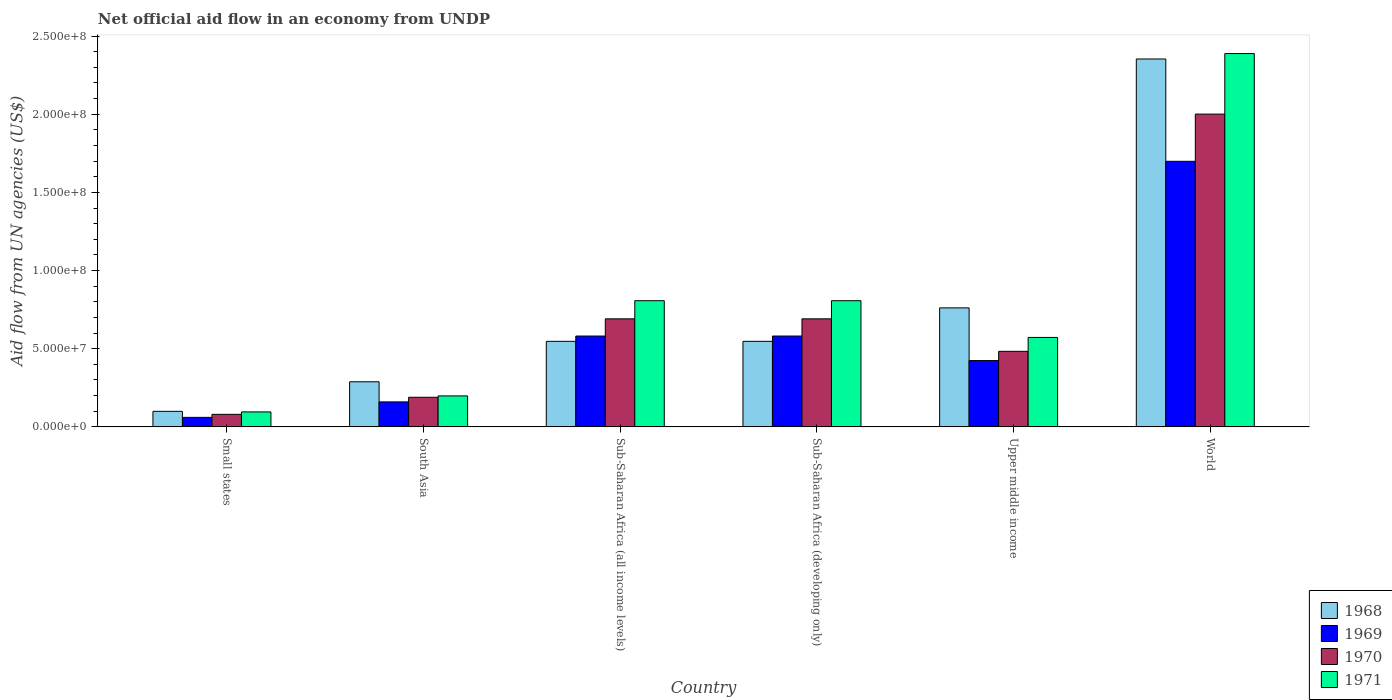How many different coloured bars are there?
Provide a short and direct response. 4. How many bars are there on the 5th tick from the left?
Your answer should be very brief. 4. How many bars are there on the 5th tick from the right?
Your answer should be very brief. 4. What is the label of the 3rd group of bars from the left?
Ensure brevity in your answer.  Sub-Saharan Africa (all income levels). What is the net official aid flow in 1968 in Sub-Saharan Africa (all income levels)?
Your answer should be compact. 5.47e+07. Across all countries, what is the maximum net official aid flow in 1968?
Your answer should be compact. 2.35e+08. Across all countries, what is the minimum net official aid flow in 1968?
Your answer should be compact. 9.94e+06. In which country was the net official aid flow in 1969 minimum?
Provide a succinct answer. Small states. What is the total net official aid flow in 1970 in the graph?
Provide a succinct answer. 4.14e+08. What is the difference between the net official aid flow in 1971 in Sub-Saharan Africa (developing only) and that in Upper middle income?
Offer a very short reply. 2.35e+07. What is the difference between the net official aid flow in 1971 in Small states and the net official aid flow in 1970 in Sub-Saharan Africa (developing only)?
Keep it short and to the point. -5.95e+07. What is the average net official aid flow in 1971 per country?
Your response must be concise. 8.11e+07. What is the difference between the net official aid flow of/in 1971 and net official aid flow of/in 1969 in Upper middle income?
Keep it short and to the point. 1.48e+07. What is the ratio of the net official aid flow in 1971 in Sub-Saharan Africa (all income levels) to that in World?
Provide a succinct answer. 0.34. Is the difference between the net official aid flow in 1971 in Sub-Saharan Africa (all income levels) and Upper middle income greater than the difference between the net official aid flow in 1969 in Sub-Saharan Africa (all income levels) and Upper middle income?
Provide a short and direct response. Yes. What is the difference between the highest and the second highest net official aid flow in 1971?
Offer a very short reply. 1.58e+08. What is the difference between the highest and the lowest net official aid flow in 1970?
Offer a very short reply. 1.92e+08. What does the 3rd bar from the left in World represents?
Offer a very short reply. 1970. What does the 4th bar from the right in Upper middle income represents?
Offer a very short reply. 1968. How many bars are there?
Ensure brevity in your answer.  24. How many countries are there in the graph?
Keep it short and to the point. 6. What is the difference between two consecutive major ticks on the Y-axis?
Provide a succinct answer. 5.00e+07. Are the values on the major ticks of Y-axis written in scientific E-notation?
Your response must be concise. Yes. How are the legend labels stacked?
Your answer should be compact. Vertical. What is the title of the graph?
Your answer should be very brief. Net official aid flow in an economy from UNDP. What is the label or title of the X-axis?
Provide a succinct answer. Country. What is the label or title of the Y-axis?
Offer a very short reply. Aid flow from UN agencies (US$). What is the Aid flow from UN agencies (US$) in 1968 in Small states?
Ensure brevity in your answer.  9.94e+06. What is the Aid flow from UN agencies (US$) in 1969 in Small states?
Keep it short and to the point. 6.08e+06. What is the Aid flow from UN agencies (US$) of 1970 in Small states?
Your response must be concise. 8.02e+06. What is the Aid flow from UN agencies (US$) in 1971 in Small states?
Offer a very short reply. 9.57e+06. What is the Aid flow from UN agencies (US$) of 1968 in South Asia?
Provide a succinct answer. 2.88e+07. What is the Aid flow from UN agencies (US$) of 1969 in South Asia?
Your answer should be compact. 1.60e+07. What is the Aid flow from UN agencies (US$) in 1970 in South Asia?
Keep it short and to the point. 1.89e+07. What is the Aid flow from UN agencies (US$) in 1971 in South Asia?
Keep it short and to the point. 1.98e+07. What is the Aid flow from UN agencies (US$) of 1968 in Sub-Saharan Africa (all income levels)?
Your answer should be compact. 5.47e+07. What is the Aid flow from UN agencies (US$) in 1969 in Sub-Saharan Africa (all income levels)?
Offer a terse response. 5.81e+07. What is the Aid flow from UN agencies (US$) of 1970 in Sub-Saharan Africa (all income levels)?
Give a very brief answer. 6.91e+07. What is the Aid flow from UN agencies (US$) of 1971 in Sub-Saharan Africa (all income levels)?
Your response must be concise. 8.07e+07. What is the Aid flow from UN agencies (US$) in 1968 in Sub-Saharan Africa (developing only)?
Provide a short and direct response. 5.47e+07. What is the Aid flow from UN agencies (US$) of 1969 in Sub-Saharan Africa (developing only)?
Offer a very short reply. 5.81e+07. What is the Aid flow from UN agencies (US$) in 1970 in Sub-Saharan Africa (developing only)?
Make the answer very short. 6.91e+07. What is the Aid flow from UN agencies (US$) in 1971 in Sub-Saharan Africa (developing only)?
Ensure brevity in your answer.  8.07e+07. What is the Aid flow from UN agencies (US$) in 1968 in Upper middle income?
Make the answer very short. 7.61e+07. What is the Aid flow from UN agencies (US$) in 1969 in Upper middle income?
Offer a very short reply. 4.24e+07. What is the Aid flow from UN agencies (US$) of 1970 in Upper middle income?
Make the answer very short. 4.83e+07. What is the Aid flow from UN agencies (US$) of 1971 in Upper middle income?
Give a very brief answer. 5.72e+07. What is the Aid flow from UN agencies (US$) of 1968 in World?
Make the answer very short. 2.35e+08. What is the Aid flow from UN agencies (US$) in 1969 in World?
Provide a succinct answer. 1.70e+08. What is the Aid flow from UN agencies (US$) of 1970 in World?
Make the answer very short. 2.00e+08. What is the Aid flow from UN agencies (US$) of 1971 in World?
Your response must be concise. 2.39e+08. Across all countries, what is the maximum Aid flow from UN agencies (US$) of 1968?
Offer a terse response. 2.35e+08. Across all countries, what is the maximum Aid flow from UN agencies (US$) of 1969?
Give a very brief answer. 1.70e+08. Across all countries, what is the maximum Aid flow from UN agencies (US$) of 1970?
Provide a short and direct response. 2.00e+08. Across all countries, what is the maximum Aid flow from UN agencies (US$) in 1971?
Your answer should be compact. 2.39e+08. Across all countries, what is the minimum Aid flow from UN agencies (US$) in 1968?
Your response must be concise. 9.94e+06. Across all countries, what is the minimum Aid flow from UN agencies (US$) of 1969?
Give a very brief answer. 6.08e+06. Across all countries, what is the minimum Aid flow from UN agencies (US$) in 1970?
Provide a succinct answer. 8.02e+06. Across all countries, what is the minimum Aid flow from UN agencies (US$) of 1971?
Your answer should be compact. 9.57e+06. What is the total Aid flow from UN agencies (US$) of 1968 in the graph?
Keep it short and to the point. 4.60e+08. What is the total Aid flow from UN agencies (US$) of 1969 in the graph?
Offer a very short reply. 3.51e+08. What is the total Aid flow from UN agencies (US$) of 1970 in the graph?
Ensure brevity in your answer.  4.14e+08. What is the total Aid flow from UN agencies (US$) in 1971 in the graph?
Ensure brevity in your answer.  4.87e+08. What is the difference between the Aid flow from UN agencies (US$) in 1968 in Small states and that in South Asia?
Offer a terse response. -1.89e+07. What is the difference between the Aid flow from UN agencies (US$) of 1969 in Small states and that in South Asia?
Ensure brevity in your answer.  -9.90e+06. What is the difference between the Aid flow from UN agencies (US$) in 1970 in Small states and that in South Asia?
Ensure brevity in your answer.  -1.09e+07. What is the difference between the Aid flow from UN agencies (US$) of 1971 in Small states and that in South Asia?
Give a very brief answer. -1.02e+07. What is the difference between the Aid flow from UN agencies (US$) in 1968 in Small states and that in Sub-Saharan Africa (all income levels)?
Provide a short and direct response. -4.48e+07. What is the difference between the Aid flow from UN agencies (US$) in 1969 in Small states and that in Sub-Saharan Africa (all income levels)?
Give a very brief answer. -5.20e+07. What is the difference between the Aid flow from UN agencies (US$) in 1970 in Small states and that in Sub-Saharan Africa (all income levels)?
Keep it short and to the point. -6.11e+07. What is the difference between the Aid flow from UN agencies (US$) of 1971 in Small states and that in Sub-Saharan Africa (all income levels)?
Provide a short and direct response. -7.11e+07. What is the difference between the Aid flow from UN agencies (US$) of 1968 in Small states and that in Sub-Saharan Africa (developing only)?
Your response must be concise. -4.48e+07. What is the difference between the Aid flow from UN agencies (US$) in 1969 in Small states and that in Sub-Saharan Africa (developing only)?
Provide a short and direct response. -5.20e+07. What is the difference between the Aid flow from UN agencies (US$) of 1970 in Small states and that in Sub-Saharan Africa (developing only)?
Your response must be concise. -6.11e+07. What is the difference between the Aid flow from UN agencies (US$) in 1971 in Small states and that in Sub-Saharan Africa (developing only)?
Offer a very short reply. -7.11e+07. What is the difference between the Aid flow from UN agencies (US$) in 1968 in Small states and that in Upper middle income?
Make the answer very short. -6.62e+07. What is the difference between the Aid flow from UN agencies (US$) in 1969 in Small states and that in Upper middle income?
Provide a short and direct response. -3.63e+07. What is the difference between the Aid flow from UN agencies (US$) of 1970 in Small states and that in Upper middle income?
Your response must be concise. -4.03e+07. What is the difference between the Aid flow from UN agencies (US$) in 1971 in Small states and that in Upper middle income?
Your response must be concise. -4.76e+07. What is the difference between the Aid flow from UN agencies (US$) of 1968 in Small states and that in World?
Offer a very short reply. -2.25e+08. What is the difference between the Aid flow from UN agencies (US$) of 1969 in Small states and that in World?
Offer a terse response. -1.64e+08. What is the difference between the Aid flow from UN agencies (US$) of 1970 in Small states and that in World?
Your answer should be very brief. -1.92e+08. What is the difference between the Aid flow from UN agencies (US$) of 1971 in Small states and that in World?
Give a very brief answer. -2.29e+08. What is the difference between the Aid flow from UN agencies (US$) of 1968 in South Asia and that in Sub-Saharan Africa (all income levels)?
Your answer should be compact. -2.59e+07. What is the difference between the Aid flow from UN agencies (US$) in 1969 in South Asia and that in Sub-Saharan Africa (all income levels)?
Provide a succinct answer. -4.21e+07. What is the difference between the Aid flow from UN agencies (US$) of 1970 in South Asia and that in Sub-Saharan Africa (all income levels)?
Your answer should be compact. -5.02e+07. What is the difference between the Aid flow from UN agencies (US$) in 1971 in South Asia and that in Sub-Saharan Africa (all income levels)?
Make the answer very short. -6.09e+07. What is the difference between the Aid flow from UN agencies (US$) in 1968 in South Asia and that in Sub-Saharan Africa (developing only)?
Ensure brevity in your answer.  -2.59e+07. What is the difference between the Aid flow from UN agencies (US$) of 1969 in South Asia and that in Sub-Saharan Africa (developing only)?
Keep it short and to the point. -4.21e+07. What is the difference between the Aid flow from UN agencies (US$) of 1970 in South Asia and that in Sub-Saharan Africa (developing only)?
Provide a succinct answer. -5.02e+07. What is the difference between the Aid flow from UN agencies (US$) in 1971 in South Asia and that in Sub-Saharan Africa (developing only)?
Your answer should be very brief. -6.09e+07. What is the difference between the Aid flow from UN agencies (US$) in 1968 in South Asia and that in Upper middle income?
Give a very brief answer. -4.73e+07. What is the difference between the Aid flow from UN agencies (US$) in 1969 in South Asia and that in Upper middle income?
Offer a terse response. -2.64e+07. What is the difference between the Aid flow from UN agencies (US$) in 1970 in South Asia and that in Upper middle income?
Your answer should be compact. -2.94e+07. What is the difference between the Aid flow from UN agencies (US$) in 1971 in South Asia and that in Upper middle income?
Offer a very short reply. -3.74e+07. What is the difference between the Aid flow from UN agencies (US$) in 1968 in South Asia and that in World?
Make the answer very short. -2.06e+08. What is the difference between the Aid flow from UN agencies (US$) of 1969 in South Asia and that in World?
Offer a terse response. -1.54e+08. What is the difference between the Aid flow from UN agencies (US$) of 1970 in South Asia and that in World?
Provide a succinct answer. -1.81e+08. What is the difference between the Aid flow from UN agencies (US$) of 1971 in South Asia and that in World?
Keep it short and to the point. -2.19e+08. What is the difference between the Aid flow from UN agencies (US$) in 1968 in Sub-Saharan Africa (all income levels) and that in Sub-Saharan Africa (developing only)?
Provide a short and direct response. 0. What is the difference between the Aid flow from UN agencies (US$) of 1969 in Sub-Saharan Africa (all income levels) and that in Sub-Saharan Africa (developing only)?
Offer a very short reply. 0. What is the difference between the Aid flow from UN agencies (US$) in 1970 in Sub-Saharan Africa (all income levels) and that in Sub-Saharan Africa (developing only)?
Provide a short and direct response. 0. What is the difference between the Aid flow from UN agencies (US$) of 1971 in Sub-Saharan Africa (all income levels) and that in Sub-Saharan Africa (developing only)?
Offer a terse response. 0. What is the difference between the Aid flow from UN agencies (US$) in 1968 in Sub-Saharan Africa (all income levels) and that in Upper middle income?
Your answer should be very brief. -2.14e+07. What is the difference between the Aid flow from UN agencies (US$) in 1969 in Sub-Saharan Africa (all income levels) and that in Upper middle income?
Ensure brevity in your answer.  1.57e+07. What is the difference between the Aid flow from UN agencies (US$) of 1970 in Sub-Saharan Africa (all income levels) and that in Upper middle income?
Provide a short and direct response. 2.08e+07. What is the difference between the Aid flow from UN agencies (US$) in 1971 in Sub-Saharan Africa (all income levels) and that in Upper middle income?
Offer a very short reply. 2.35e+07. What is the difference between the Aid flow from UN agencies (US$) of 1968 in Sub-Saharan Africa (all income levels) and that in World?
Your response must be concise. -1.81e+08. What is the difference between the Aid flow from UN agencies (US$) of 1969 in Sub-Saharan Africa (all income levels) and that in World?
Offer a very short reply. -1.12e+08. What is the difference between the Aid flow from UN agencies (US$) in 1970 in Sub-Saharan Africa (all income levels) and that in World?
Provide a short and direct response. -1.31e+08. What is the difference between the Aid flow from UN agencies (US$) of 1971 in Sub-Saharan Africa (all income levels) and that in World?
Your answer should be very brief. -1.58e+08. What is the difference between the Aid flow from UN agencies (US$) of 1968 in Sub-Saharan Africa (developing only) and that in Upper middle income?
Your answer should be very brief. -2.14e+07. What is the difference between the Aid flow from UN agencies (US$) of 1969 in Sub-Saharan Africa (developing only) and that in Upper middle income?
Your response must be concise. 1.57e+07. What is the difference between the Aid flow from UN agencies (US$) of 1970 in Sub-Saharan Africa (developing only) and that in Upper middle income?
Keep it short and to the point. 2.08e+07. What is the difference between the Aid flow from UN agencies (US$) of 1971 in Sub-Saharan Africa (developing only) and that in Upper middle income?
Offer a terse response. 2.35e+07. What is the difference between the Aid flow from UN agencies (US$) of 1968 in Sub-Saharan Africa (developing only) and that in World?
Keep it short and to the point. -1.81e+08. What is the difference between the Aid flow from UN agencies (US$) of 1969 in Sub-Saharan Africa (developing only) and that in World?
Your answer should be very brief. -1.12e+08. What is the difference between the Aid flow from UN agencies (US$) in 1970 in Sub-Saharan Africa (developing only) and that in World?
Ensure brevity in your answer.  -1.31e+08. What is the difference between the Aid flow from UN agencies (US$) in 1971 in Sub-Saharan Africa (developing only) and that in World?
Make the answer very short. -1.58e+08. What is the difference between the Aid flow from UN agencies (US$) in 1968 in Upper middle income and that in World?
Ensure brevity in your answer.  -1.59e+08. What is the difference between the Aid flow from UN agencies (US$) of 1969 in Upper middle income and that in World?
Offer a terse response. -1.27e+08. What is the difference between the Aid flow from UN agencies (US$) in 1970 in Upper middle income and that in World?
Make the answer very short. -1.52e+08. What is the difference between the Aid flow from UN agencies (US$) in 1971 in Upper middle income and that in World?
Provide a succinct answer. -1.82e+08. What is the difference between the Aid flow from UN agencies (US$) of 1968 in Small states and the Aid flow from UN agencies (US$) of 1969 in South Asia?
Your answer should be very brief. -6.04e+06. What is the difference between the Aid flow from UN agencies (US$) in 1968 in Small states and the Aid flow from UN agencies (US$) in 1970 in South Asia?
Give a very brief answer. -8.99e+06. What is the difference between the Aid flow from UN agencies (US$) of 1968 in Small states and the Aid flow from UN agencies (US$) of 1971 in South Asia?
Your response must be concise. -9.87e+06. What is the difference between the Aid flow from UN agencies (US$) of 1969 in Small states and the Aid flow from UN agencies (US$) of 1970 in South Asia?
Make the answer very short. -1.28e+07. What is the difference between the Aid flow from UN agencies (US$) of 1969 in Small states and the Aid flow from UN agencies (US$) of 1971 in South Asia?
Your answer should be very brief. -1.37e+07. What is the difference between the Aid flow from UN agencies (US$) in 1970 in Small states and the Aid flow from UN agencies (US$) in 1971 in South Asia?
Offer a very short reply. -1.18e+07. What is the difference between the Aid flow from UN agencies (US$) in 1968 in Small states and the Aid flow from UN agencies (US$) in 1969 in Sub-Saharan Africa (all income levels)?
Your answer should be compact. -4.82e+07. What is the difference between the Aid flow from UN agencies (US$) of 1968 in Small states and the Aid flow from UN agencies (US$) of 1970 in Sub-Saharan Africa (all income levels)?
Your answer should be very brief. -5.92e+07. What is the difference between the Aid flow from UN agencies (US$) in 1968 in Small states and the Aid flow from UN agencies (US$) in 1971 in Sub-Saharan Africa (all income levels)?
Your response must be concise. -7.08e+07. What is the difference between the Aid flow from UN agencies (US$) of 1969 in Small states and the Aid flow from UN agencies (US$) of 1970 in Sub-Saharan Africa (all income levels)?
Provide a succinct answer. -6.30e+07. What is the difference between the Aid flow from UN agencies (US$) of 1969 in Small states and the Aid flow from UN agencies (US$) of 1971 in Sub-Saharan Africa (all income levels)?
Ensure brevity in your answer.  -7.46e+07. What is the difference between the Aid flow from UN agencies (US$) in 1970 in Small states and the Aid flow from UN agencies (US$) in 1971 in Sub-Saharan Africa (all income levels)?
Your answer should be compact. -7.27e+07. What is the difference between the Aid flow from UN agencies (US$) in 1968 in Small states and the Aid flow from UN agencies (US$) in 1969 in Sub-Saharan Africa (developing only)?
Your answer should be very brief. -4.82e+07. What is the difference between the Aid flow from UN agencies (US$) in 1968 in Small states and the Aid flow from UN agencies (US$) in 1970 in Sub-Saharan Africa (developing only)?
Offer a very short reply. -5.92e+07. What is the difference between the Aid flow from UN agencies (US$) in 1968 in Small states and the Aid flow from UN agencies (US$) in 1971 in Sub-Saharan Africa (developing only)?
Give a very brief answer. -7.08e+07. What is the difference between the Aid flow from UN agencies (US$) in 1969 in Small states and the Aid flow from UN agencies (US$) in 1970 in Sub-Saharan Africa (developing only)?
Your response must be concise. -6.30e+07. What is the difference between the Aid flow from UN agencies (US$) of 1969 in Small states and the Aid flow from UN agencies (US$) of 1971 in Sub-Saharan Africa (developing only)?
Your answer should be very brief. -7.46e+07. What is the difference between the Aid flow from UN agencies (US$) in 1970 in Small states and the Aid flow from UN agencies (US$) in 1971 in Sub-Saharan Africa (developing only)?
Give a very brief answer. -7.27e+07. What is the difference between the Aid flow from UN agencies (US$) of 1968 in Small states and the Aid flow from UN agencies (US$) of 1969 in Upper middle income?
Provide a short and direct response. -3.25e+07. What is the difference between the Aid flow from UN agencies (US$) in 1968 in Small states and the Aid flow from UN agencies (US$) in 1970 in Upper middle income?
Give a very brief answer. -3.84e+07. What is the difference between the Aid flow from UN agencies (US$) in 1968 in Small states and the Aid flow from UN agencies (US$) in 1971 in Upper middle income?
Your answer should be very brief. -4.73e+07. What is the difference between the Aid flow from UN agencies (US$) in 1969 in Small states and the Aid flow from UN agencies (US$) in 1970 in Upper middle income?
Keep it short and to the point. -4.22e+07. What is the difference between the Aid flow from UN agencies (US$) of 1969 in Small states and the Aid flow from UN agencies (US$) of 1971 in Upper middle income?
Give a very brief answer. -5.11e+07. What is the difference between the Aid flow from UN agencies (US$) of 1970 in Small states and the Aid flow from UN agencies (US$) of 1971 in Upper middle income?
Provide a succinct answer. -4.92e+07. What is the difference between the Aid flow from UN agencies (US$) in 1968 in Small states and the Aid flow from UN agencies (US$) in 1969 in World?
Make the answer very short. -1.60e+08. What is the difference between the Aid flow from UN agencies (US$) in 1968 in Small states and the Aid flow from UN agencies (US$) in 1970 in World?
Your answer should be very brief. -1.90e+08. What is the difference between the Aid flow from UN agencies (US$) in 1968 in Small states and the Aid flow from UN agencies (US$) in 1971 in World?
Offer a terse response. -2.29e+08. What is the difference between the Aid flow from UN agencies (US$) of 1969 in Small states and the Aid flow from UN agencies (US$) of 1970 in World?
Provide a succinct answer. -1.94e+08. What is the difference between the Aid flow from UN agencies (US$) of 1969 in Small states and the Aid flow from UN agencies (US$) of 1971 in World?
Offer a terse response. -2.33e+08. What is the difference between the Aid flow from UN agencies (US$) in 1970 in Small states and the Aid flow from UN agencies (US$) in 1971 in World?
Give a very brief answer. -2.31e+08. What is the difference between the Aid flow from UN agencies (US$) of 1968 in South Asia and the Aid flow from UN agencies (US$) of 1969 in Sub-Saharan Africa (all income levels)?
Give a very brief answer. -2.92e+07. What is the difference between the Aid flow from UN agencies (US$) in 1968 in South Asia and the Aid flow from UN agencies (US$) in 1970 in Sub-Saharan Africa (all income levels)?
Give a very brief answer. -4.03e+07. What is the difference between the Aid flow from UN agencies (US$) in 1968 in South Asia and the Aid flow from UN agencies (US$) in 1971 in Sub-Saharan Africa (all income levels)?
Offer a terse response. -5.19e+07. What is the difference between the Aid flow from UN agencies (US$) in 1969 in South Asia and the Aid flow from UN agencies (US$) in 1970 in Sub-Saharan Africa (all income levels)?
Ensure brevity in your answer.  -5.31e+07. What is the difference between the Aid flow from UN agencies (US$) of 1969 in South Asia and the Aid flow from UN agencies (US$) of 1971 in Sub-Saharan Africa (all income levels)?
Your response must be concise. -6.47e+07. What is the difference between the Aid flow from UN agencies (US$) in 1970 in South Asia and the Aid flow from UN agencies (US$) in 1971 in Sub-Saharan Africa (all income levels)?
Keep it short and to the point. -6.18e+07. What is the difference between the Aid flow from UN agencies (US$) in 1968 in South Asia and the Aid flow from UN agencies (US$) in 1969 in Sub-Saharan Africa (developing only)?
Provide a succinct answer. -2.92e+07. What is the difference between the Aid flow from UN agencies (US$) of 1968 in South Asia and the Aid flow from UN agencies (US$) of 1970 in Sub-Saharan Africa (developing only)?
Provide a succinct answer. -4.03e+07. What is the difference between the Aid flow from UN agencies (US$) of 1968 in South Asia and the Aid flow from UN agencies (US$) of 1971 in Sub-Saharan Africa (developing only)?
Your response must be concise. -5.19e+07. What is the difference between the Aid flow from UN agencies (US$) of 1969 in South Asia and the Aid flow from UN agencies (US$) of 1970 in Sub-Saharan Africa (developing only)?
Your answer should be compact. -5.31e+07. What is the difference between the Aid flow from UN agencies (US$) of 1969 in South Asia and the Aid flow from UN agencies (US$) of 1971 in Sub-Saharan Africa (developing only)?
Your answer should be compact. -6.47e+07. What is the difference between the Aid flow from UN agencies (US$) of 1970 in South Asia and the Aid flow from UN agencies (US$) of 1971 in Sub-Saharan Africa (developing only)?
Provide a succinct answer. -6.18e+07. What is the difference between the Aid flow from UN agencies (US$) in 1968 in South Asia and the Aid flow from UN agencies (US$) in 1969 in Upper middle income?
Your response must be concise. -1.36e+07. What is the difference between the Aid flow from UN agencies (US$) of 1968 in South Asia and the Aid flow from UN agencies (US$) of 1970 in Upper middle income?
Give a very brief answer. -1.95e+07. What is the difference between the Aid flow from UN agencies (US$) in 1968 in South Asia and the Aid flow from UN agencies (US$) in 1971 in Upper middle income?
Your answer should be compact. -2.84e+07. What is the difference between the Aid flow from UN agencies (US$) in 1969 in South Asia and the Aid flow from UN agencies (US$) in 1970 in Upper middle income?
Your answer should be compact. -3.24e+07. What is the difference between the Aid flow from UN agencies (US$) of 1969 in South Asia and the Aid flow from UN agencies (US$) of 1971 in Upper middle income?
Provide a succinct answer. -4.12e+07. What is the difference between the Aid flow from UN agencies (US$) in 1970 in South Asia and the Aid flow from UN agencies (US$) in 1971 in Upper middle income?
Your answer should be very brief. -3.83e+07. What is the difference between the Aid flow from UN agencies (US$) of 1968 in South Asia and the Aid flow from UN agencies (US$) of 1969 in World?
Offer a terse response. -1.41e+08. What is the difference between the Aid flow from UN agencies (US$) in 1968 in South Asia and the Aid flow from UN agencies (US$) in 1970 in World?
Your answer should be compact. -1.71e+08. What is the difference between the Aid flow from UN agencies (US$) in 1968 in South Asia and the Aid flow from UN agencies (US$) in 1971 in World?
Provide a short and direct response. -2.10e+08. What is the difference between the Aid flow from UN agencies (US$) of 1969 in South Asia and the Aid flow from UN agencies (US$) of 1970 in World?
Your answer should be compact. -1.84e+08. What is the difference between the Aid flow from UN agencies (US$) of 1969 in South Asia and the Aid flow from UN agencies (US$) of 1971 in World?
Offer a very short reply. -2.23e+08. What is the difference between the Aid flow from UN agencies (US$) of 1970 in South Asia and the Aid flow from UN agencies (US$) of 1971 in World?
Provide a succinct answer. -2.20e+08. What is the difference between the Aid flow from UN agencies (US$) of 1968 in Sub-Saharan Africa (all income levels) and the Aid flow from UN agencies (US$) of 1969 in Sub-Saharan Africa (developing only)?
Offer a terse response. -3.39e+06. What is the difference between the Aid flow from UN agencies (US$) in 1968 in Sub-Saharan Africa (all income levels) and the Aid flow from UN agencies (US$) in 1970 in Sub-Saharan Africa (developing only)?
Your answer should be very brief. -1.44e+07. What is the difference between the Aid flow from UN agencies (US$) in 1968 in Sub-Saharan Africa (all income levels) and the Aid flow from UN agencies (US$) in 1971 in Sub-Saharan Africa (developing only)?
Your answer should be very brief. -2.60e+07. What is the difference between the Aid flow from UN agencies (US$) of 1969 in Sub-Saharan Africa (all income levels) and the Aid flow from UN agencies (US$) of 1970 in Sub-Saharan Africa (developing only)?
Make the answer very short. -1.10e+07. What is the difference between the Aid flow from UN agencies (US$) in 1969 in Sub-Saharan Africa (all income levels) and the Aid flow from UN agencies (US$) in 1971 in Sub-Saharan Africa (developing only)?
Your answer should be very brief. -2.26e+07. What is the difference between the Aid flow from UN agencies (US$) of 1970 in Sub-Saharan Africa (all income levels) and the Aid flow from UN agencies (US$) of 1971 in Sub-Saharan Africa (developing only)?
Offer a terse response. -1.16e+07. What is the difference between the Aid flow from UN agencies (US$) in 1968 in Sub-Saharan Africa (all income levels) and the Aid flow from UN agencies (US$) in 1969 in Upper middle income?
Make the answer very short. 1.23e+07. What is the difference between the Aid flow from UN agencies (US$) of 1968 in Sub-Saharan Africa (all income levels) and the Aid flow from UN agencies (US$) of 1970 in Upper middle income?
Offer a very short reply. 6.38e+06. What is the difference between the Aid flow from UN agencies (US$) of 1968 in Sub-Saharan Africa (all income levels) and the Aid flow from UN agencies (US$) of 1971 in Upper middle income?
Provide a short and direct response. -2.50e+06. What is the difference between the Aid flow from UN agencies (US$) of 1969 in Sub-Saharan Africa (all income levels) and the Aid flow from UN agencies (US$) of 1970 in Upper middle income?
Your answer should be compact. 9.77e+06. What is the difference between the Aid flow from UN agencies (US$) in 1969 in Sub-Saharan Africa (all income levels) and the Aid flow from UN agencies (US$) in 1971 in Upper middle income?
Your answer should be compact. 8.90e+05. What is the difference between the Aid flow from UN agencies (US$) in 1970 in Sub-Saharan Africa (all income levels) and the Aid flow from UN agencies (US$) in 1971 in Upper middle income?
Your answer should be very brief. 1.19e+07. What is the difference between the Aid flow from UN agencies (US$) in 1968 in Sub-Saharan Africa (all income levels) and the Aid flow from UN agencies (US$) in 1969 in World?
Provide a succinct answer. -1.15e+08. What is the difference between the Aid flow from UN agencies (US$) in 1968 in Sub-Saharan Africa (all income levels) and the Aid flow from UN agencies (US$) in 1970 in World?
Give a very brief answer. -1.45e+08. What is the difference between the Aid flow from UN agencies (US$) of 1968 in Sub-Saharan Africa (all income levels) and the Aid flow from UN agencies (US$) of 1971 in World?
Provide a short and direct response. -1.84e+08. What is the difference between the Aid flow from UN agencies (US$) of 1969 in Sub-Saharan Africa (all income levels) and the Aid flow from UN agencies (US$) of 1970 in World?
Give a very brief answer. -1.42e+08. What is the difference between the Aid flow from UN agencies (US$) in 1969 in Sub-Saharan Africa (all income levels) and the Aid flow from UN agencies (US$) in 1971 in World?
Provide a short and direct response. -1.81e+08. What is the difference between the Aid flow from UN agencies (US$) of 1970 in Sub-Saharan Africa (all income levels) and the Aid flow from UN agencies (US$) of 1971 in World?
Provide a succinct answer. -1.70e+08. What is the difference between the Aid flow from UN agencies (US$) in 1968 in Sub-Saharan Africa (developing only) and the Aid flow from UN agencies (US$) in 1969 in Upper middle income?
Provide a short and direct response. 1.23e+07. What is the difference between the Aid flow from UN agencies (US$) in 1968 in Sub-Saharan Africa (developing only) and the Aid flow from UN agencies (US$) in 1970 in Upper middle income?
Ensure brevity in your answer.  6.38e+06. What is the difference between the Aid flow from UN agencies (US$) of 1968 in Sub-Saharan Africa (developing only) and the Aid flow from UN agencies (US$) of 1971 in Upper middle income?
Offer a very short reply. -2.50e+06. What is the difference between the Aid flow from UN agencies (US$) in 1969 in Sub-Saharan Africa (developing only) and the Aid flow from UN agencies (US$) in 1970 in Upper middle income?
Offer a very short reply. 9.77e+06. What is the difference between the Aid flow from UN agencies (US$) in 1969 in Sub-Saharan Africa (developing only) and the Aid flow from UN agencies (US$) in 1971 in Upper middle income?
Offer a terse response. 8.90e+05. What is the difference between the Aid flow from UN agencies (US$) in 1970 in Sub-Saharan Africa (developing only) and the Aid flow from UN agencies (US$) in 1971 in Upper middle income?
Offer a very short reply. 1.19e+07. What is the difference between the Aid flow from UN agencies (US$) in 1968 in Sub-Saharan Africa (developing only) and the Aid flow from UN agencies (US$) in 1969 in World?
Offer a very short reply. -1.15e+08. What is the difference between the Aid flow from UN agencies (US$) of 1968 in Sub-Saharan Africa (developing only) and the Aid flow from UN agencies (US$) of 1970 in World?
Offer a very short reply. -1.45e+08. What is the difference between the Aid flow from UN agencies (US$) of 1968 in Sub-Saharan Africa (developing only) and the Aid flow from UN agencies (US$) of 1971 in World?
Provide a succinct answer. -1.84e+08. What is the difference between the Aid flow from UN agencies (US$) in 1969 in Sub-Saharan Africa (developing only) and the Aid flow from UN agencies (US$) in 1970 in World?
Keep it short and to the point. -1.42e+08. What is the difference between the Aid flow from UN agencies (US$) in 1969 in Sub-Saharan Africa (developing only) and the Aid flow from UN agencies (US$) in 1971 in World?
Provide a short and direct response. -1.81e+08. What is the difference between the Aid flow from UN agencies (US$) in 1970 in Sub-Saharan Africa (developing only) and the Aid flow from UN agencies (US$) in 1971 in World?
Give a very brief answer. -1.70e+08. What is the difference between the Aid flow from UN agencies (US$) of 1968 in Upper middle income and the Aid flow from UN agencies (US$) of 1969 in World?
Provide a short and direct response. -9.38e+07. What is the difference between the Aid flow from UN agencies (US$) of 1968 in Upper middle income and the Aid flow from UN agencies (US$) of 1970 in World?
Give a very brief answer. -1.24e+08. What is the difference between the Aid flow from UN agencies (US$) of 1968 in Upper middle income and the Aid flow from UN agencies (US$) of 1971 in World?
Your answer should be compact. -1.63e+08. What is the difference between the Aid flow from UN agencies (US$) in 1969 in Upper middle income and the Aid flow from UN agencies (US$) in 1970 in World?
Make the answer very short. -1.58e+08. What is the difference between the Aid flow from UN agencies (US$) of 1969 in Upper middle income and the Aid flow from UN agencies (US$) of 1971 in World?
Ensure brevity in your answer.  -1.96e+08. What is the difference between the Aid flow from UN agencies (US$) in 1970 in Upper middle income and the Aid flow from UN agencies (US$) in 1971 in World?
Offer a terse response. -1.90e+08. What is the average Aid flow from UN agencies (US$) in 1968 per country?
Your answer should be compact. 7.66e+07. What is the average Aid flow from UN agencies (US$) of 1969 per country?
Ensure brevity in your answer.  5.84e+07. What is the average Aid flow from UN agencies (US$) in 1970 per country?
Your response must be concise. 6.89e+07. What is the average Aid flow from UN agencies (US$) of 1971 per country?
Your answer should be very brief. 8.11e+07. What is the difference between the Aid flow from UN agencies (US$) of 1968 and Aid flow from UN agencies (US$) of 1969 in Small states?
Give a very brief answer. 3.86e+06. What is the difference between the Aid flow from UN agencies (US$) in 1968 and Aid flow from UN agencies (US$) in 1970 in Small states?
Ensure brevity in your answer.  1.92e+06. What is the difference between the Aid flow from UN agencies (US$) of 1968 and Aid flow from UN agencies (US$) of 1971 in Small states?
Offer a very short reply. 3.70e+05. What is the difference between the Aid flow from UN agencies (US$) in 1969 and Aid flow from UN agencies (US$) in 1970 in Small states?
Give a very brief answer. -1.94e+06. What is the difference between the Aid flow from UN agencies (US$) in 1969 and Aid flow from UN agencies (US$) in 1971 in Small states?
Keep it short and to the point. -3.49e+06. What is the difference between the Aid flow from UN agencies (US$) in 1970 and Aid flow from UN agencies (US$) in 1971 in Small states?
Provide a short and direct response. -1.55e+06. What is the difference between the Aid flow from UN agencies (US$) of 1968 and Aid flow from UN agencies (US$) of 1969 in South Asia?
Provide a succinct answer. 1.29e+07. What is the difference between the Aid flow from UN agencies (US$) in 1968 and Aid flow from UN agencies (US$) in 1970 in South Asia?
Offer a very short reply. 9.92e+06. What is the difference between the Aid flow from UN agencies (US$) of 1968 and Aid flow from UN agencies (US$) of 1971 in South Asia?
Offer a very short reply. 9.04e+06. What is the difference between the Aid flow from UN agencies (US$) of 1969 and Aid flow from UN agencies (US$) of 1970 in South Asia?
Keep it short and to the point. -2.95e+06. What is the difference between the Aid flow from UN agencies (US$) in 1969 and Aid flow from UN agencies (US$) in 1971 in South Asia?
Make the answer very short. -3.83e+06. What is the difference between the Aid flow from UN agencies (US$) in 1970 and Aid flow from UN agencies (US$) in 1971 in South Asia?
Keep it short and to the point. -8.80e+05. What is the difference between the Aid flow from UN agencies (US$) in 1968 and Aid flow from UN agencies (US$) in 1969 in Sub-Saharan Africa (all income levels)?
Provide a short and direct response. -3.39e+06. What is the difference between the Aid flow from UN agencies (US$) in 1968 and Aid flow from UN agencies (US$) in 1970 in Sub-Saharan Africa (all income levels)?
Provide a short and direct response. -1.44e+07. What is the difference between the Aid flow from UN agencies (US$) of 1968 and Aid flow from UN agencies (US$) of 1971 in Sub-Saharan Africa (all income levels)?
Provide a short and direct response. -2.60e+07. What is the difference between the Aid flow from UN agencies (US$) of 1969 and Aid flow from UN agencies (US$) of 1970 in Sub-Saharan Africa (all income levels)?
Provide a short and direct response. -1.10e+07. What is the difference between the Aid flow from UN agencies (US$) in 1969 and Aid flow from UN agencies (US$) in 1971 in Sub-Saharan Africa (all income levels)?
Offer a terse response. -2.26e+07. What is the difference between the Aid flow from UN agencies (US$) of 1970 and Aid flow from UN agencies (US$) of 1971 in Sub-Saharan Africa (all income levels)?
Your answer should be very brief. -1.16e+07. What is the difference between the Aid flow from UN agencies (US$) of 1968 and Aid flow from UN agencies (US$) of 1969 in Sub-Saharan Africa (developing only)?
Your answer should be very brief. -3.39e+06. What is the difference between the Aid flow from UN agencies (US$) of 1968 and Aid flow from UN agencies (US$) of 1970 in Sub-Saharan Africa (developing only)?
Keep it short and to the point. -1.44e+07. What is the difference between the Aid flow from UN agencies (US$) of 1968 and Aid flow from UN agencies (US$) of 1971 in Sub-Saharan Africa (developing only)?
Give a very brief answer. -2.60e+07. What is the difference between the Aid flow from UN agencies (US$) of 1969 and Aid flow from UN agencies (US$) of 1970 in Sub-Saharan Africa (developing only)?
Your answer should be compact. -1.10e+07. What is the difference between the Aid flow from UN agencies (US$) of 1969 and Aid flow from UN agencies (US$) of 1971 in Sub-Saharan Africa (developing only)?
Give a very brief answer. -2.26e+07. What is the difference between the Aid flow from UN agencies (US$) of 1970 and Aid flow from UN agencies (US$) of 1971 in Sub-Saharan Africa (developing only)?
Keep it short and to the point. -1.16e+07. What is the difference between the Aid flow from UN agencies (US$) in 1968 and Aid flow from UN agencies (US$) in 1969 in Upper middle income?
Your answer should be compact. 3.37e+07. What is the difference between the Aid flow from UN agencies (US$) of 1968 and Aid flow from UN agencies (US$) of 1970 in Upper middle income?
Make the answer very short. 2.78e+07. What is the difference between the Aid flow from UN agencies (US$) of 1968 and Aid flow from UN agencies (US$) of 1971 in Upper middle income?
Offer a very short reply. 1.89e+07. What is the difference between the Aid flow from UN agencies (US$) in 1969 and Aid flow from UN agencies (US$) in 1970 in Upper middle income?
Give a very brief answer. -5.92e+06. What is the difference between the Aid flow from UN agencies (US$) of 1969 and Aid flow from UN agencies (US$) of 1971 in Upper middle income?
Give a very brief answer. -1.48e+07. What is the difference between the Aid flow from UN agencies (US$) of 1970 and Aid flow from UN agencies (US$) of 1971 in Upper middle income?
Offer a very short reply. -8.88e+06. What is the difference between the Aid flow from UN agencies (US$) of 1968 and Aid flow from UN agencies (US$) of 1969 in World?
Your answer should be compact. 6.54e+07. What is the difference between the Aid flow from UN agencies (US$) of 1968 and Aid flow from UN agencies (US$) of 1970 in World?
Ensure brevity in your answer.  3.52e+07. What is the difference between the Aid flow from UN agencies (US$) of 1968 and Aid flow from UN agencies (US$) of 1971 in World?
Give a very brief answer. -3.49e+06. What is the difference between the Aid flow from UN agencies (US$) of 1969 and Aid flow from UN agencies (US$) of 1970 in World?
Your answer should be very brief. -3.02e+07. What is the difference between the Aid flow from UN agencies (US$) of 1969 and Aid flow from UN agencies (US$) of 1971 in World?
Your answer should be very brief. -6.89e+07. What is the difference between the Aid flow from UN agencies (US$) in 1970 and Aid flow from UN agencies (US$) in 1971 in World?
Offer a terse response. -3.87e+07. What is the ratio of the Aid flow from UN agencies (US$) of 1968 in Small states to that in South Asia?
Make the answer very short. 0.34. What is the ratio of the Aid flow from UN agencies (US$) of 1969 in Small states to that in South Asia?
Keep it short and to the point. 0.38. What is the ratio of the Aid flow from UN agencies (US$) of 1970 in Small states to that in South Asia?
Make the answer very short. 0.42. What is the ratio of the Aid flow from UN agencies (US$) in 1971 in Small states to that in South Asia?
Provide a succinct answer. 0.48. What is the ratio of the Aid flow from UN agencies (US$) of 1968 in Small states to that in Sub-Saharan Africa (all income levels)?
Keep it short and to the point. 0.18. What is the ratio of the Aid flow from UN agencies (US$) in 1969 in Small states to that in Sub-Saharan Africa (all income levels)?
Give a very brief answer. 0.1. What is the ratio of the Aid flow from UN agencies (US$) in 1970 in Small states to that in Sub-Saharan Africa (all income levels)?
Offer a very short reply. 0.12. What is the ratio of the Aid flow from UN agencies (US$) of 1971 in Small states to that in Sub-Saharan Africa (all income levels)?
Offer a terse response. 0.12. What is the ratio of the Aid flow from UN agencies (US$) in 1968 in Small states to that in Sub-Saharan Africa (developing only)?
Your response must be concise. 0.18. What is the ratio of the Aid flow from UN agencies (US$) in 1969 in Small states to that in Sub-Saharan Africa (developing only)?
Provide a succinct answer. 0.1. What is the ratio of the Aid flow from UN agencies (US$) in 1970 in Small states to that in Sub-Saharan Africa (developing only)?
Your answer should be very brief. 0.12. What is the ratio of the Aid flow from UN agencies (US$) in 1971 in Small states to that in Sub-Saharan Africa (developing only)?
Your response must be concise. 0.12. What is the ratio of the Aid flow from UN agencies (US$) of 1968 in Small states to that in Upper middle income?
Your answer should be very brief. 0.13. What is the ratio of the Aid flow from UN agencies (US$) in 1969 in Small states to that in Upper middle income?
Your answer should be very brief. 0.14. What is the ratio of the Aid flow from UN agencies (US$) of 1970 in Small states to that in Upper middle income?
Make the answer very short. 0.17. What is the ratio of the Aid flow from UN agencies (US$) in 1971 in Small states to that in Upper middle income?
Offer a terse response. 0.17. What is the ratio of the Aid flow from UN agencies (US$) of 1968 in Small states to that in World?
Offer a terse response. 0.04. What is the ratio of the Aid flow from UN agencies (US$) in 1969 in Small states to that in World?
Ensure brevity in your answer.  0.04. What is the ratio of the Aid flow from UN agencies (US$) of 1970 in Small states to that in World?
Your response must be concise. 0.04. What is the ratio of the Aid flow from UN agencies (US$) of 1971 in Small states to that in World?
Your answer should be compact. 0.04. What is the ratio of the Aid flow from UN agencies (US$) in 1968 in South Asia to that in Sub-Saharan Africa (all income levels)?
Provide a succinct answer. 0.53. What is the ratio of the Aid flow from UN agencies (US$) of 1969 in South Asia to that in Sub-Saharan Africa (all income levels)?
Your answer should be compact. 0.28. What is the ratio of the Aid flow from UN agencies (US$) in 1970 in South Asia to that in Sub-Saharan Africa (all income levels)?
Offer a terse response. 0.27. What is the ratio of the Aid flow from UN agencies (US$) of 1971 in South Asia to that in Sub-Saharan Africa (all income levels)?
Provide a short and direct response. 0.25. What is the ratio of the Aid flow from UN agencies (US$) in 1968 in South Asia to that in Sub-Saharan Africa (developing only)?
Offer a terse response. 0.53. What is the ratio of the Aid flow from UN agencies (US$) in 1969 in South Asia to that in Sub-Saharan Africa (developing only)?
Keep it short and to the point. 0.28. What is the ratio of the Aid flow from UN agencies (US$) of 1970 in South Asia to that in Sub-Saharan Africa (developing only)?
Your response must be concise. 0.27. What is the ratio of the Aid flow from UN agencies (US$) of 1971 in South Asia to that in Sub-Saharan Africa (developing only)?
Your answer should be very brief. 0.25. What is the ratio of the Aid flow from UN agencies (US$) of 1968 in South Asia to that in Upper middle income?
Make the answer very short. 0.38. What is the ratio of the Aid flow from UN agencies (US$) of 1969 in South Asia to that in Upper middle income?
Make the answer very short. 0.38. What is the ratio of the Aid flow from UN agencies (US$) of 1970 in South Asia to that in Upper middle income?
Keep it short and to the point. 0.39. What is the ratio of the Aid flow from UN agencies (US$) of 1971 in South Asia to that in Upper middle income?
Make the answer very short. 0.35. What is the ratio of the Aid flow from UN agencies (US$) in 1968 in South Asia to that in World?
Your response must be concise. 0.12. What is the ratio of the Aid flow from UN agencies (US$) in 1969 in South Asia to that in World?
Keep it short and to the point. 0.09. What is the ratio of the Aid flow from UN agencies (US$) in 1970 in South Asia to that in World?
Give a very brief answer. 0.09. What is the ratio of the Aid flow from UN agencies (US$) of 1971 in South Asia to that in World?
Provide a succinct answer. 0.08. What is the ratio of the Aid flow from UN agencies (US$) of 1969 in Sub-Saharan Africa (all income levels) to that in Sub-Saharan Africa (developing only)?
Provide a succinct answer. 1. What is the ratio of the Aid flow from UN agencies (US$) in 1971 in Sub-Saharan Africa (all income levels) to that in Sub-Saharan Africa (developing only)?
Your response must be concise. 1. What is the ratio of the Aid flow from UN agencies (US$) in 1968 in Sub-Saharan Africa (all income levels) to that in Upper middle income?
Your answer should be compact. 0.72. What is the ratio of the Aid flow from UN agencies (US$) of 1969 in Sub-Saharan Africa (all income levels) to that in Upper middle income?
Offer a very short reply. 1.37. What is the ratio of the Aid flow from UN agencies (US$) in 1970 in Sub-Saharan Africa (all income levels) to that in Upper middle income?
Provide a succinct answer. 1.43. What is the ratio of the Aid flow from UN agencies (US$) in 1971 in Sub-Saharan Africa (all income levels) to that in Upper middle income?
Your answer should be very brief. 1.41. What is the ratio of the Aid flow from UN agencies (US$) in 1968 in Sub-Saharan Africa (all income levels) to that in World?
Your answer should be compact. 0.23. What is the ratio of the Aid flow from UN agencies (US$) in 1969 in Sub-Saharan Africa (all income levels) to that in World?
Give a very brief answer. 0.34. What is the ratio of the Aid flow from UN agencies (US$) in 1970 in Sub-Saharan Africa (all income levels) to that in World?
Provide a succinct answer. 0.35. What is the ratio of the Aid flow from UN agencies (US$) in 1971 in Sub-Saharan Africa (all income levels) to that in World?
Provide a succinct answer. 0.34. What is the ratio of the Aid flow from UN agencies (US$) in 1968 in Sub-Saharan Africa (developing only) to that in Upper middle income?
Make the answer very short. 0.72. What is the ratio of the Aid flow from UN agencies (US$) of 1969 in Sub-Saharan Africa (developing only) to that in Upper middle income?
Make the answer very short. 1.37. What is the ratio of the Aid flow from UN agencies (US$) of 1970 in Sub-Saharan Africa (developing only) to that in Upper middle income?
Offer a terse response. 1.43. What is the ratio of the Aid flow from UN agencies (US$) of 1971 in Sub-Saharan Africa (developing only) to that in Upper middle income?
Your response must be concise. 1.41. What is the ratio of the Aid flow from UN agencies (US$) in 1968 in Sub-Saharan Africa (developing only) to that in World?
Make the answer very short. 0.23. What is the ratio of the Aid flow from UN agencies (US$) of 1969 in Sub-Saharan Africa (developing only) to that in World?
Offer a very short reply. 0.34. What is the ratio of the Aid flow from UN agencies (US$) in 1970 in Sub-Saharan Africa (developing only) to that in World?
Keep it short and to the point. 0.35. What is the ratio of the Aid flow from UN agencies (US$) in 1971 in Sub-Saharan Africa (developing only) to that in World?
Your response must be concise. 0.34. What is the ratio of the Aid flow from UN agencies (US$) of 1968 in Upper middle income to that in World?
Give a very brief answer. 0.32. What is the ratio of the Aid flow from UN agencies (US$) of 1969 in Upper middle income to that in World?
Your answer should be very brief. 0.25. What is the ratio of the Aid flow from UN agencies (US$) in 1970 in Upper middle income to that in World?
Make the answer very short. 0.24. What is the ratio of the Aid flow from UN agencies (US$) of 1971 in Upper middle income to that in World?
Make the answer very short. 0.24. What is the difference between the highest and the second highest Aid flow from UN agencies (US$) of 1968?
Your response must be concise. 1.59e+08. What is the difference between the highest and the second highest Aid flow from UN agencies (US$) of 1969?
Your answer should be very brief. 1.12e+08. What is the difference between the highest and the second highest Aid flow from UN agencies (US$) of 1970?
Give a very brief answer. 1.31e+08. What is the difference between the highest and the second highest Aid flow from UN agencies (US$) of 1971?
Offer a terse response. 1.58e+08. What is the difference between the highest and the lowest Aid flow from UN agencies (US$) of 1968?
Offer a very short reply. 2.25e+08. What is the difference between the highest and the lowest Aid flow from UN agencies (US$) in 1969?
Offer a terse response. 1.64e+08. What is the difference between the highest and the lowest Aid flow from UN agencies (US$) in 1970?
Give a very brief answer. 1.92e+08. What is the difference between the highest and the lowest Aid flow from UN agencies (US$) of 1971?
Give a very brief answer. 2.29e+08. 